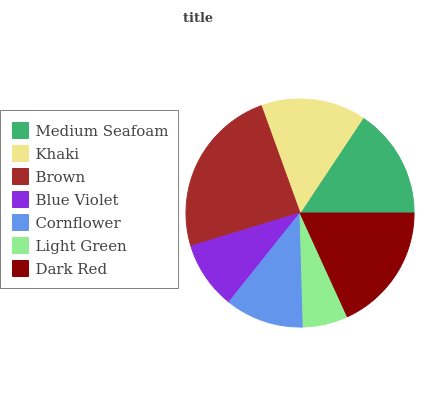Is Light Green the minimum?
Answer yes or no. Yes. Is Brown the maximum?
Answer yes or no. Yes. Is Khaki the minimum?
Answer yes or no. No. Is Khaki the maximum?
Answer yes or no. No. Is Medium Seafoam greater than Khaki?
Answer yes or no. Yes. Is Khaki less than Medium Seafoam?
Answer yes or no. Yes. Is Khaki greater than Medium Seafoam?
Answer yes or no. No. Is Medium Seafoam less than Khaki?
Answer yes or no. No. Is Khaki the high median?
Answer yes or no. Yes. Is Khaki the low median?
Answer yes or no. Yes. Is Light Green the high median?
Answer yes or no. No. Is Brown the low median?
Answer yes or no. No. 